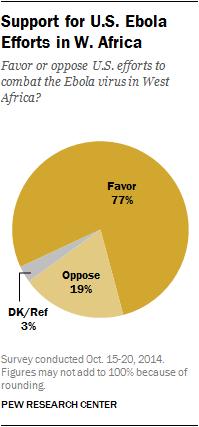Specify some key components in this picture. The sum of the two smallest segments is less than the largest segment, contrary to what is expected. The color of the segment is gray, and its value is 3%. 